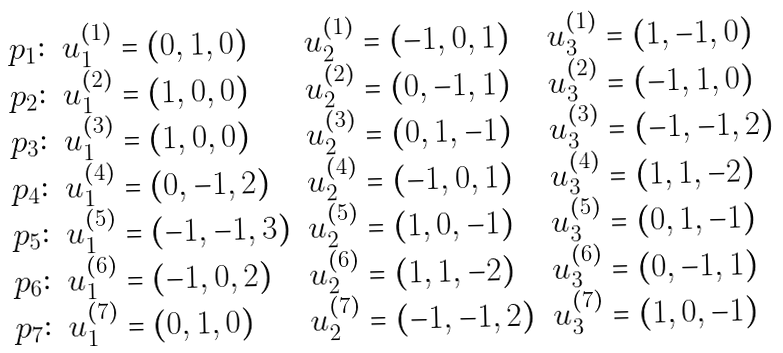Convert formula to latex. <formula><loc_0><loc_0><loc_500><loc_500>\begin{array} { l l l l } p _ { 1 } \colon & u _ { 1 } ^ { ( 1 ) } = ( 0 , 1 , 0 ) & u _ { 2 } ^ { ( 1 ) } = ( - 1 , 0 , 1 ) & u _ { 3 } ^ { ( 1 ) } = ( 1 , - 1 , 0 ) \\ p _ { 2 } \colon & u _ { 1 } ^ { ( 2 ) } = ( 1 , 0 , 0 ) & u _ { 2 } ^ { ( 2 ) } = ( 0 , - 1 , 1 ) & u _ { 3 } ^ { ( 2 ) } = ( - 1 , 1 , 0 ) \\ p _ { 3 } \colon & u _ { 1 } ^ { ( 3 ) } = ( 1 , 0 , 0 ) & u _ { 2 } ^ { ( 3 ) } = ( 0 , 1 , - 1 ) & u _ { 3 } ^ { ( 3 ) } = ( - 1 , - 1 , 2 ) \\ p _ { 4 } \colon & u _ { 1 } ^ { ( 4 ) } = ( 0 , - 1 , 2 ) & u _ { 2 } ^ { ( 4 ) } = ( - 1 , 0 , 1 ) & u _ { 3 } ^ { ( 4 ) } = ( 1 , 1 , - 2 ) \\ p _ { 5 } \colon & u _ { 1 } ^ { ( 5 ) } = ( - 1 , - 1 , 3 ) & u _ { 2 } ^ { ( 5 ) } = ( 1 , 0 , - 1 ) & u _ { 3 } ^ { ( 5 ) } = ( 0 , 1 , - 1 ) \\ p _ { 6 } \colon & u _ { 1 } ^ { ( 6 ) } = ( - 1 , 0 , 2 ) & u _ { 2 } ^ { ( 6 ) } = ( 1 , 1 , - 2 ) & u _ { 3 } ^ { ( 6 ) } = ( 0 , - 1 , 1 ) \\ p _ { 7 } \colon & u _ { 1 } ^ { ( 7 ) } = ( 0 , 1 , 0 ) & u _ { 2 } ^ { ( 7 ) } = ( - 1 , - 1 , 2 ) & u _ { 3 } ^ { ( 7 ) } = ( 1 , 0 , - 1 ) \\ \end{array}</formula> 